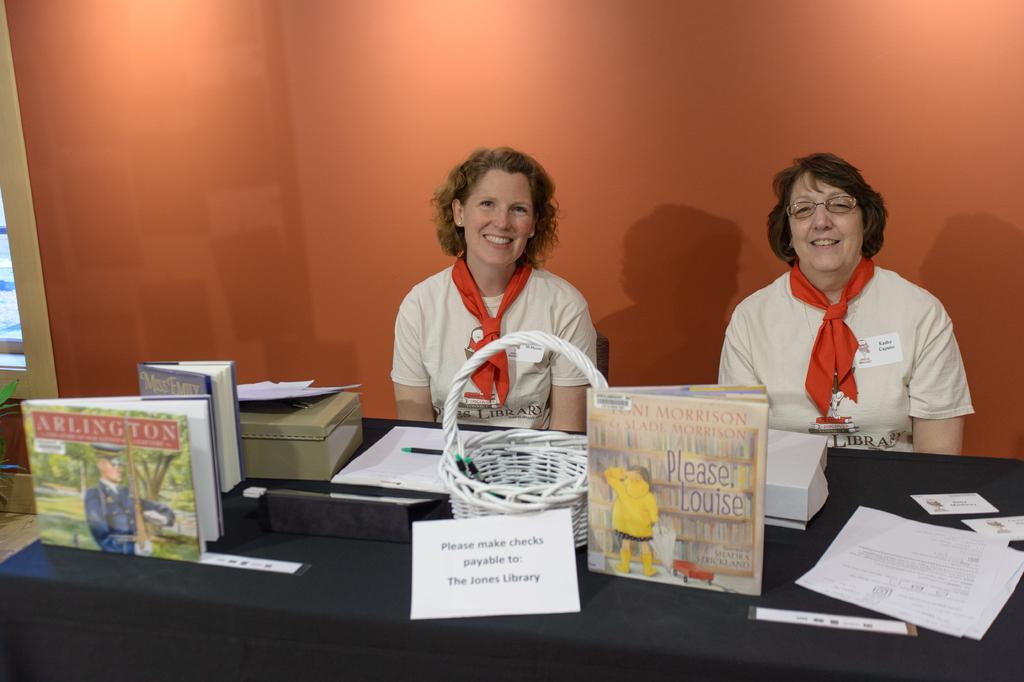What can be seen in the background of the image? There is a wall in the image. What are the two people in the image doing? The two people are sitting on chairs in the image. What is on the table in the image? There are papers, books, and a basket on the table in the image. What type of dog is sitting next to the people in the image? There is no dog present in the image. What humorous element can be seen in the image? There is no humor or joke depicted in the image. Is there any gold or gold-colored object visible in the image? There is no gold or gold-colored object present in the image. 